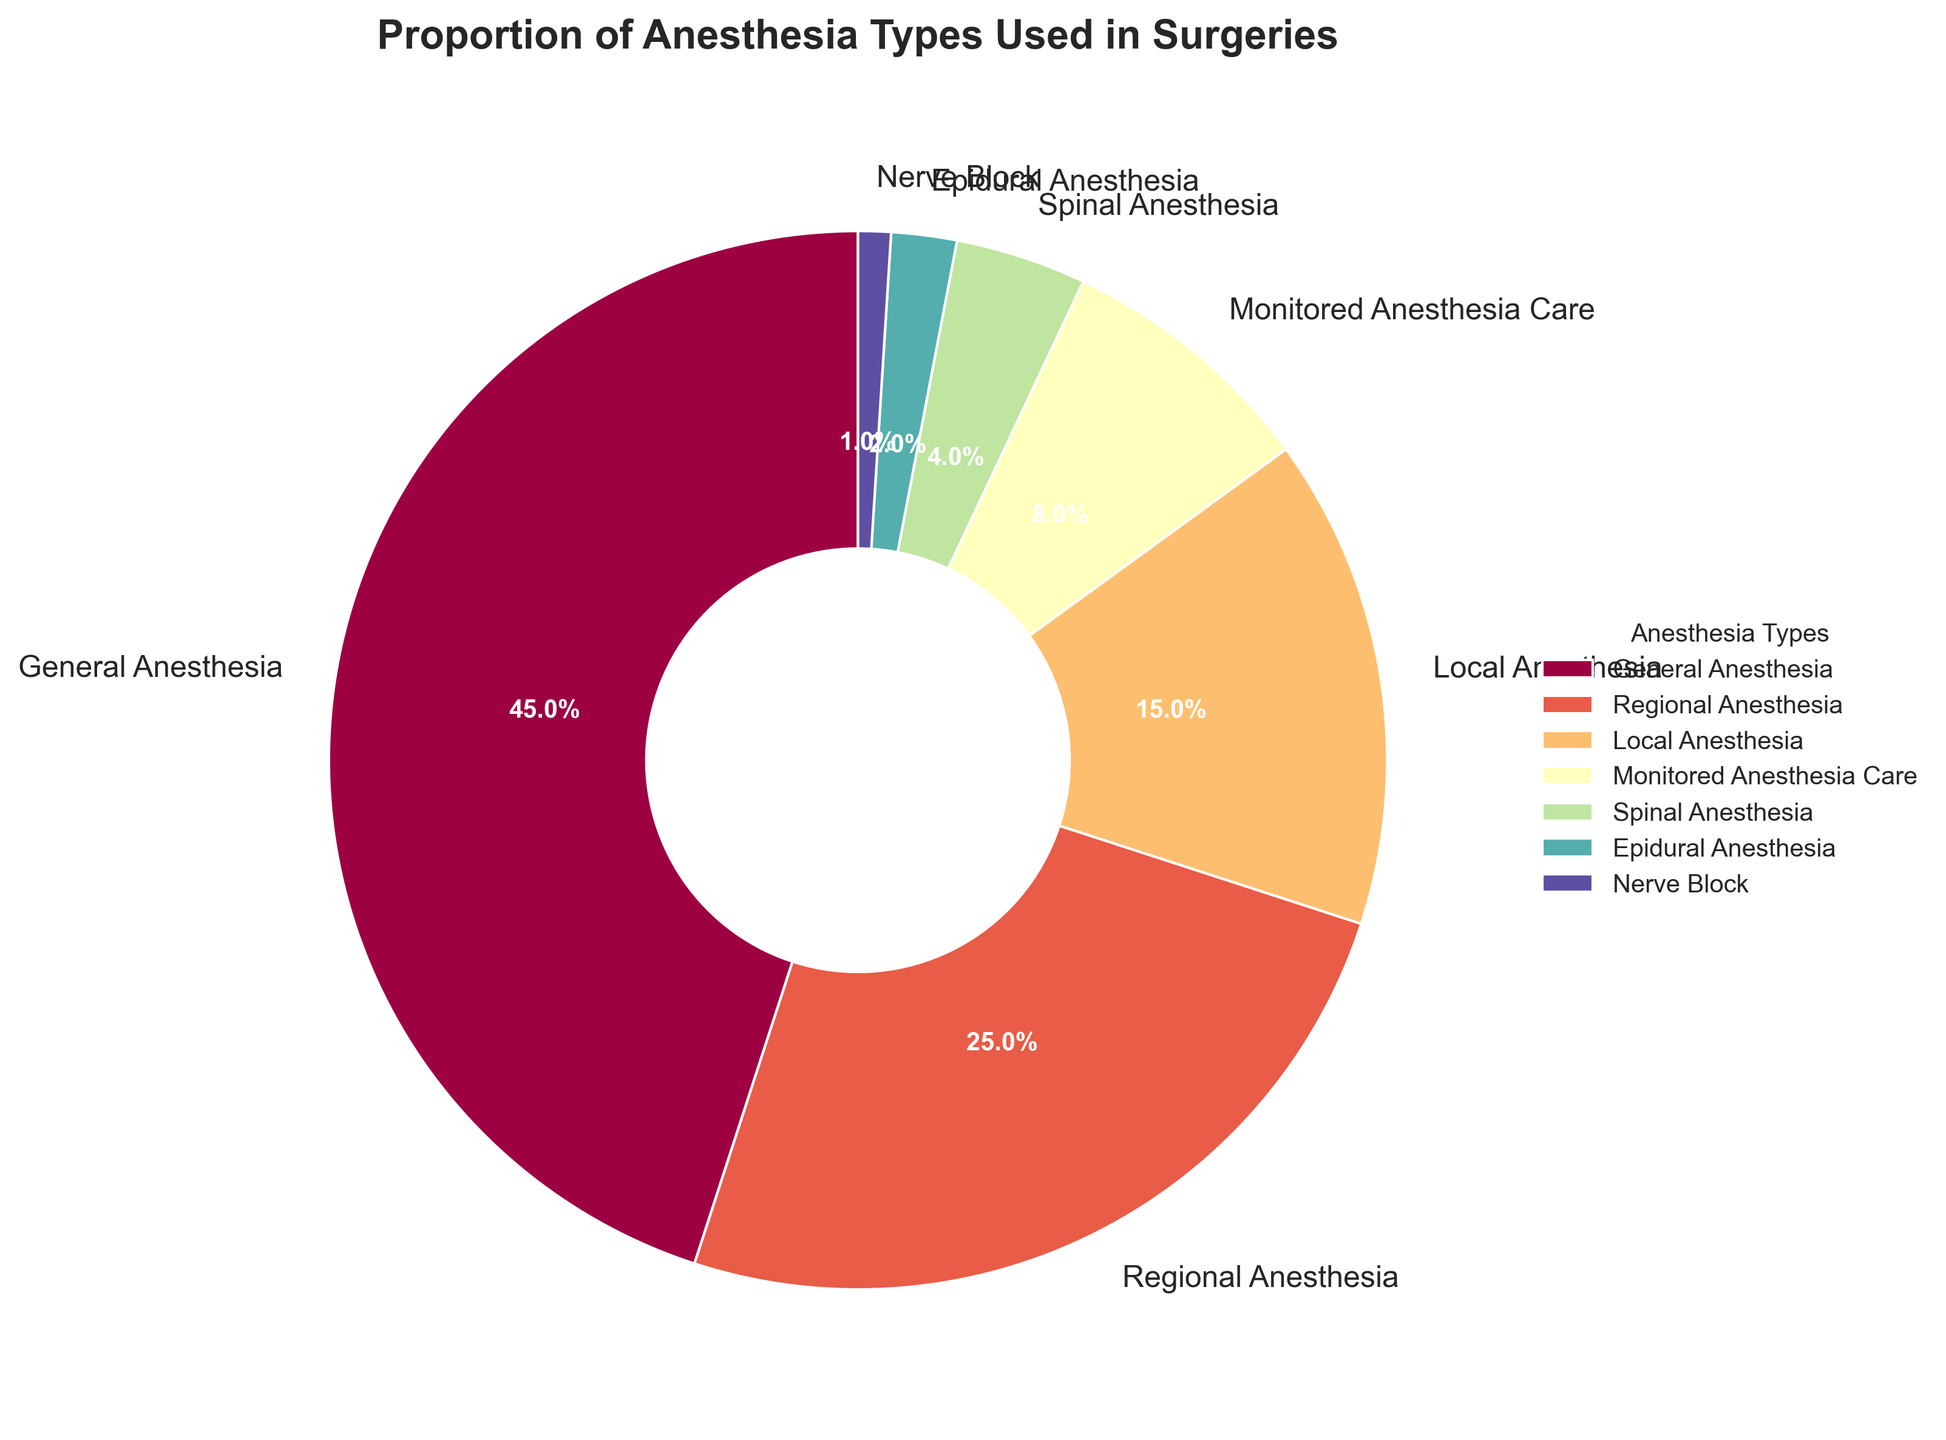What percentage of surgeries used General Anesthesia? The pie chart has slices labeled with the percentage of each type of anesthesia used. The slice for General Anesthesia has a label of 45%.
Answer: 45% What is the combined proportion of surgeries using Regional Anesthesia and Local Anesthesia? To find the combined proportion, sum the percentages of Regional Anesthesia and Local Anesthesia, which are 25% and 15% respectively. So, 25% + 15% = 40%.
Answer: 40% Which anesthesia type is used the least? By looking at the pie chart, the smallest slice is labeled "Nerve Block" with a percentage of 1%.
Answer: Nerve Block How many types of anesthesia are used in less than 10% of surgeries? The pie chart shows slices for Monitored Anesthesia Care (8%), Spinal Anesthesia (4%), Epidural Anesthesia (2%), and Nerve Block (1%), all of which are less than 10%. Hence, there are 4 types.
Answer: 4 Compare the usage of Monitored Anesthesia Care and Spinal Anesthesia. Which is used more and by how much? Monitored Anesthesia Care is 8% and Spinal Anesthesia is 4%. To find the difference, subtract 4% from 8%, which gives us 4%.
Answer: Monitored Anesthesia Care by 4% What percentage of surgeries do not use General, Regional, or Local Anesthesia? Subtract the combined percentages of General Anesthesia (45%), Regional Anesthesia (25%), and Local Anesthesia (15%) from 100%. So, 100% - (45% + 25% + 15%) = 15%.
Answer: 15% Is the proportion of Local Anesthesia usage higher or lower than Monitored Anesthesia Care? The pie chart shows that Local Anesthesia is 15% and Monitored Anesthesia Care is 8%. Thus, Local Anesthesia usage is higher.
Answer: Higher Which anesthesia type accounts for nearly a quarter of the surgeries? The pie chart shows that Regional Anesthesia has a percentage of 25%, which is about one-quarter of the total.
Answer: Regional Anesthesia Among the lesser-used anesthesia types, which type is used more than Epidural Anesthesia but less than Local Anesthesia? The pie chart shows Spinal Anesthesia at 4% and Epidural Anesthesia at 2%, both less than Local Anesthesia at 15%.
Answer: Spinal Anesthesia What is the visual color representation used for General Anesthesia in the pie chart? The specific color for General Anesthesia can be identified visually from the pie chart slice that corresponds to General Anesthesia's 45%.
Answer: (The actual visual color name based on the color palette used in the chart, e.g., "Blue", "Red".) 